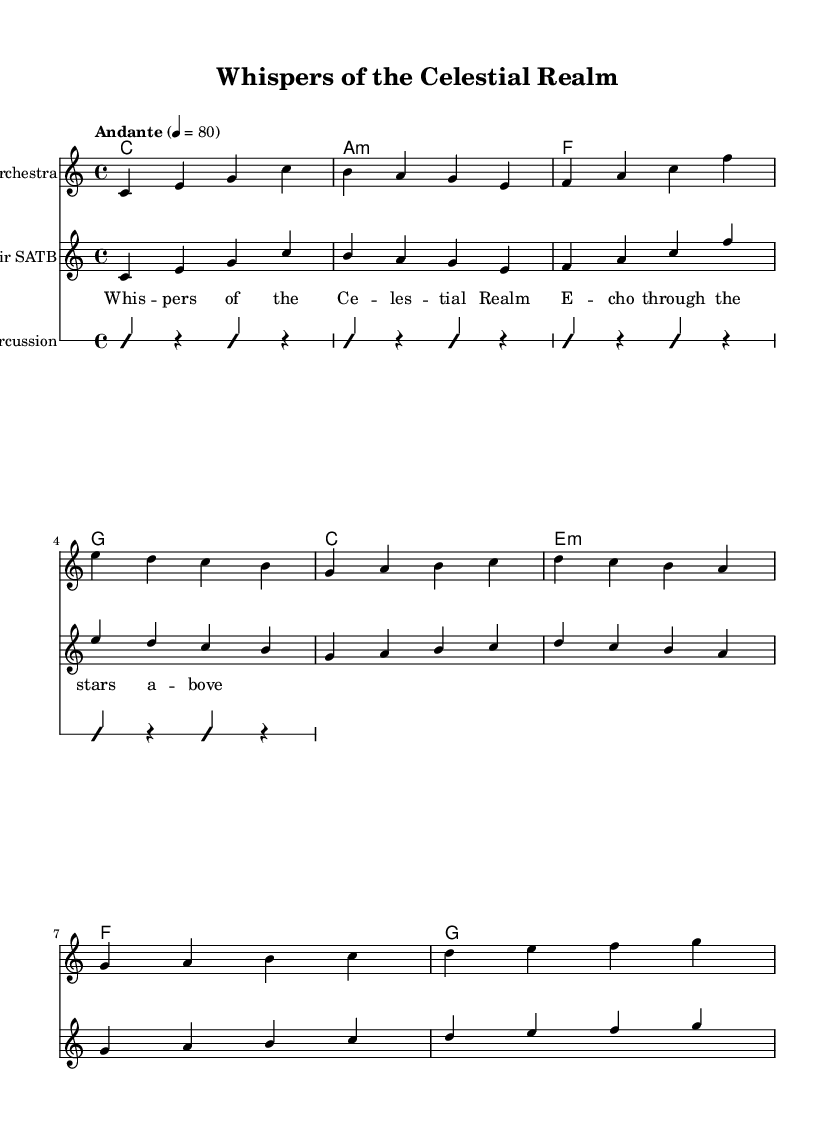What is the key signature of this music? The key signature is indicated by the "#" symbols in the key signature section, but there are none shown here, indicating it is in C major, which has no sharps or flats.
Answer: C major What is the time signature of this music? The time signature is found at the beginning of the score, represented by the numbers 4 over 4, indicating four beats per measure.
Answer: 4/4 What is the tempo marking of this piece? The tempo marking "Andante" is placed above the measures before the melody starts, indicating the speed of the music.
Answer: Andante How many measures are there in the melody section? The melody is written across a series of measures indicated by vertical lines, counting them gives a total of 8 measures.
Answer: 8 What vocal arrangement is indicated in the score? The score specifies a "Choir SATB" in one of the staff parts, indicating a four-part vocal arrangement typically involving soprano, alto, tenor, and bass.
Answer: Choir SATB What kind of instruments are indicated in this score? The score mentions "Orchestra" for the melody staff and specifies "Percussion" for the improvisation section, indicating it utilizes orchestral instrumentation.
Answer: Orchestra and Percussion What is the lyrical theme evident in the text? The lyrics provided with the melody describe celestial concepts (whispers, stars), suggestive of a fantasy or ethereal theme.
Answer: Celestial Realm 